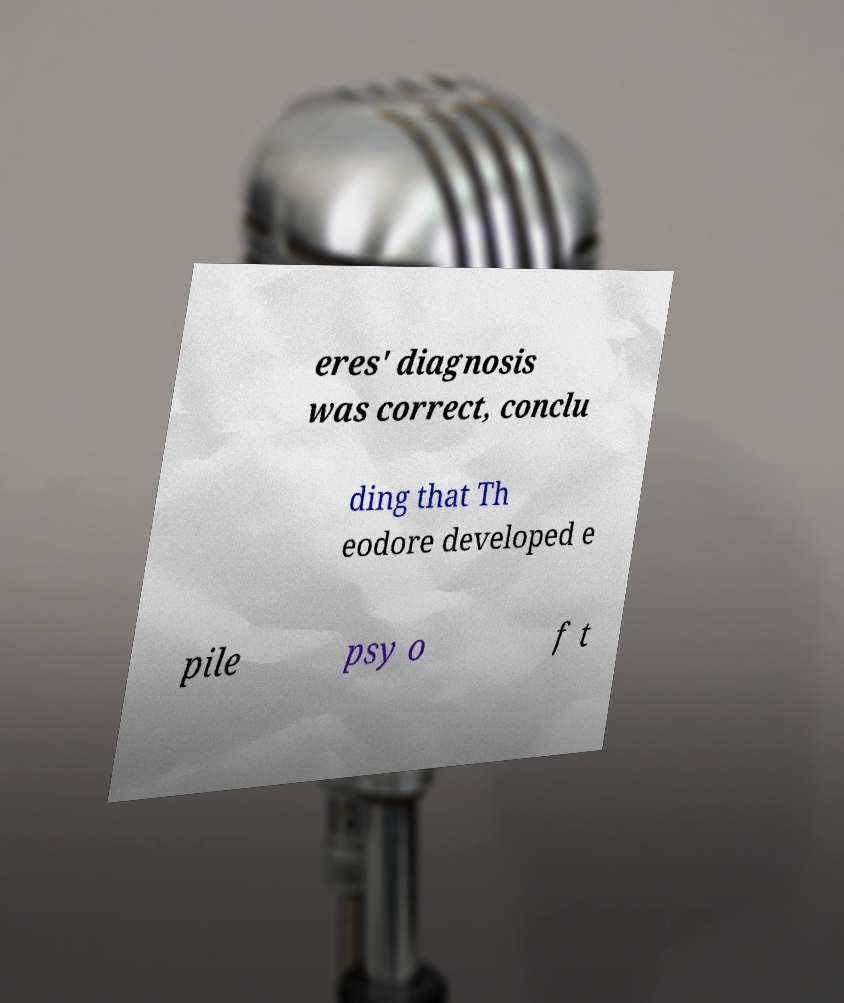Please read and relay the text visible in this image. What does it say? eres' diagnosis was correct, conclu ding that Th eodore developed e pile psy o f t 